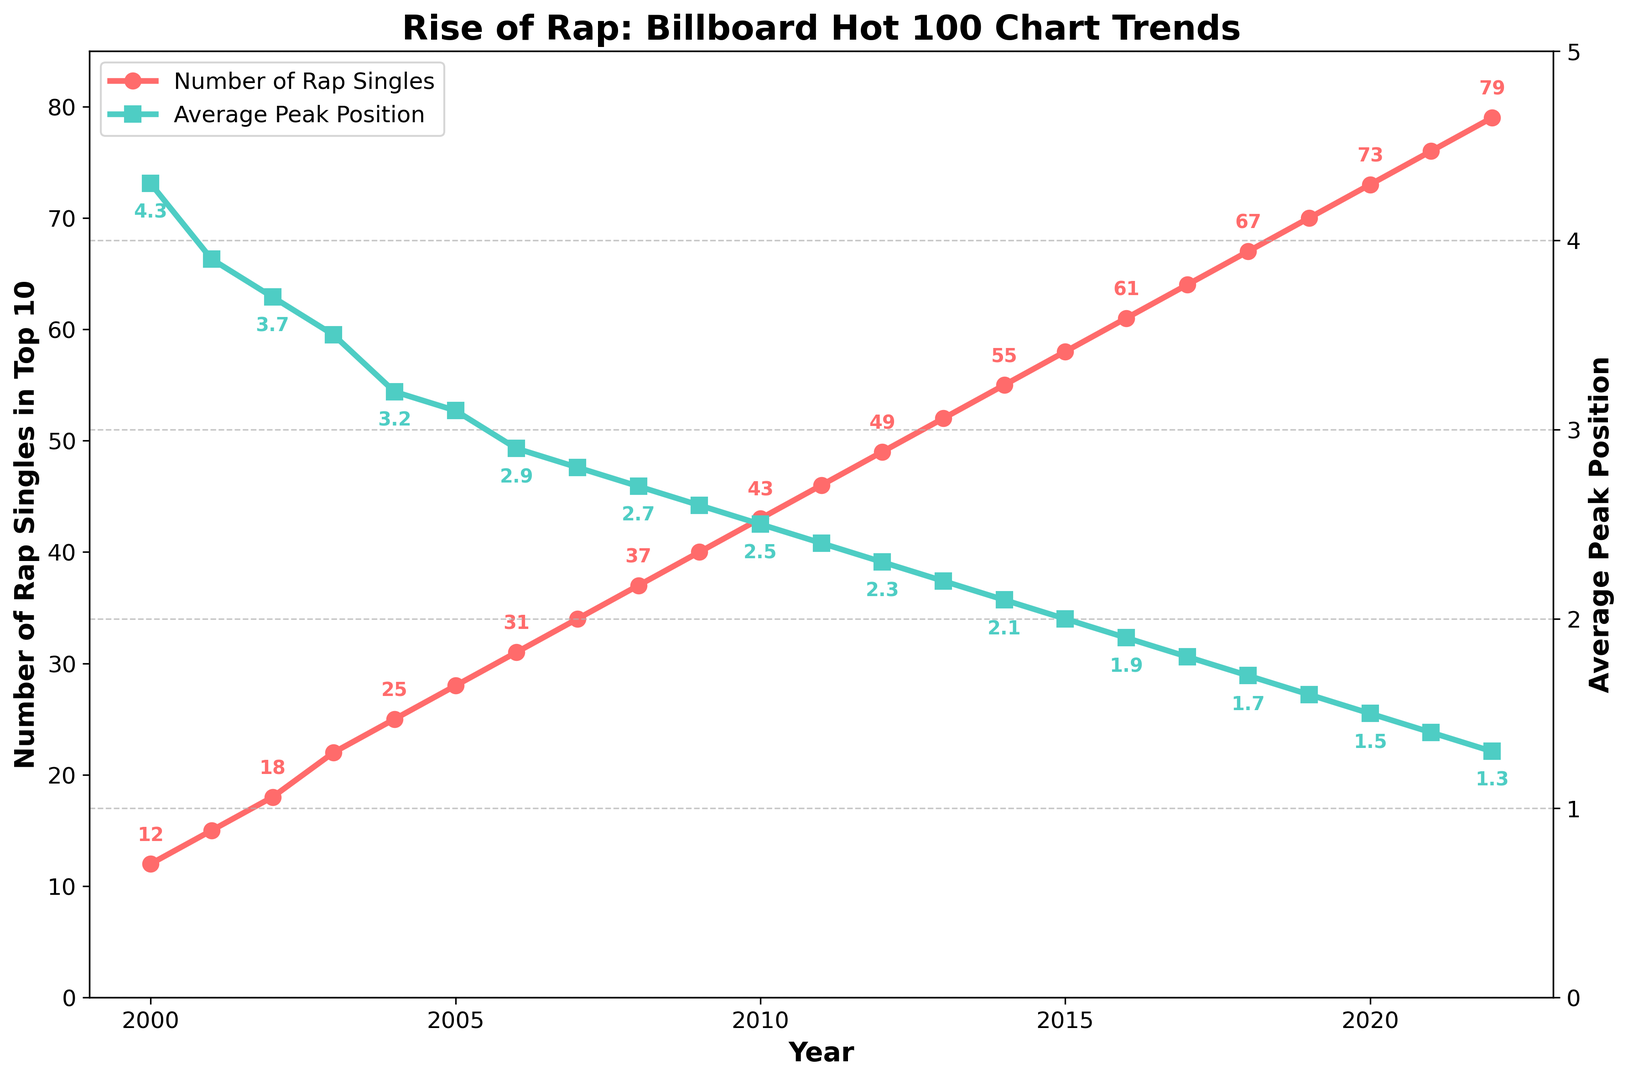What's the trend in the number of rap singles in the Top 10 from 2000 to 2022? The number of rap singles in the Top 10 shows a steady increase from 12 in 2000 to 79 in 2022. This indicates growing popularity and presence of rap music on the Billboard Hot 100 chart over the years.
Answer: Steady increase What is the peak position trend for rap singles from 2000 to 2022? The average peak position has shown a consistent improvement, decreasing from 4.3 in 2000 to 1.3 in 2022, meaning rap singles are reaching higher positions on average on the Billboard Hot 100 chart.
Answer: Consistent improvement In which year was there the highest number of rap singles in the Top 10 and what was the average peak position that year? In 2022, there were 79 rap singles in the Top 10, and the average peak position was 1.3.
Answer: 2022, 1.3 How many more rap singles were in the Top 10 in 2012 compared to 2005? In 2012, there were 49 rap singles in the Top 10 compared to 28 in 2005. The difference is 49 - 28.
Answer: 21 How does the average peak position in 2010 compare to that in 2000? The average peak position in 2010 was 2.5, while in 2000 it was 4.3. Therefore, the average peak position improved from 4.3 to 2.5.
Answer: Improved Which year had a greater rate of increase in the number of rap singles in the Top 10, 2009 to 2010 or 2019 to 2020? From 2009 to 2010, the increase was 43 - 40 = 3 rap singles. From 2019 to 2020, the increase was 73 - 70 = 3 rap singles. Both periods had the same increase rate.
Answer: Same What color represents the average peak position line in the plot? The line representing the average peak position is colored green.
Answer: Green Does the chart indicate a general trend of improvement or decline in the average peak positions of rap singles? The general trend in the chart indicates an improvement in the average peak positions of rap singles, as the values consistently decrease from 4.3 in 2000 to 1.3 in 2022.
Answer: Improvement How does the number of rap singles in the Top 10 in 2003 compare to 2006? In 2003, there were 22 rap singles in the Top 10, and in 2006 there were 31. Therefore, 2006 had more rap singles in the Top 10 compared to 2003.
Answer: 2006 had more 